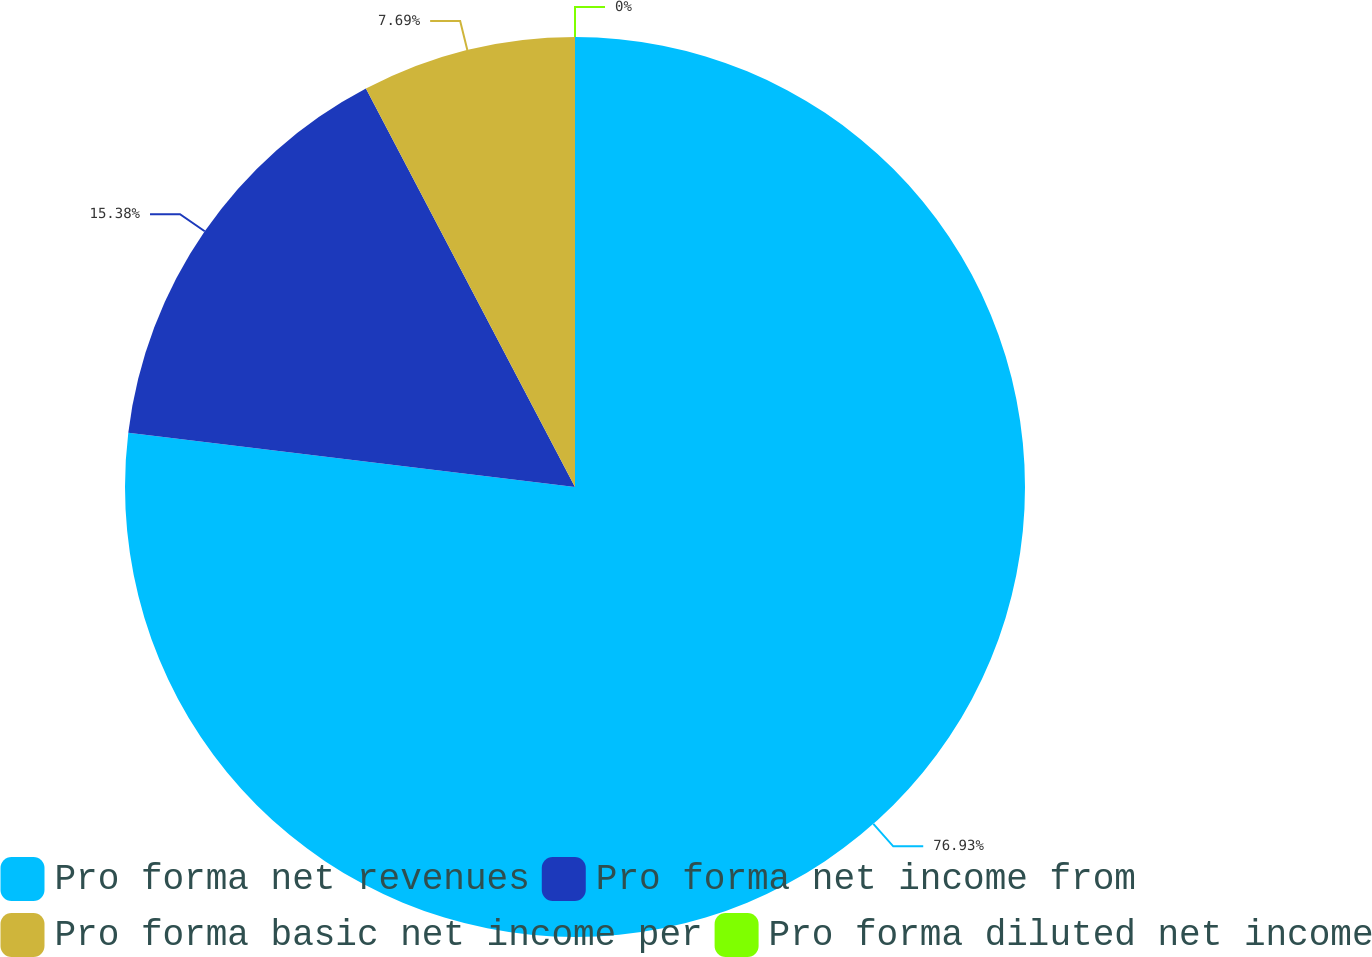Convert chart. <chart><loc_0><loc_0><loc_500><loc_500><pie_chart><fcel>Pro forma net revenues<fcel>Pro forma net income from<fcel>Pro forma basic net income per<fcel>Pro forma diluted net income<nl><fcel>76.92%<fcel>15.38%<fcel>7.69%<fcel>0.0%<nl></chart> 